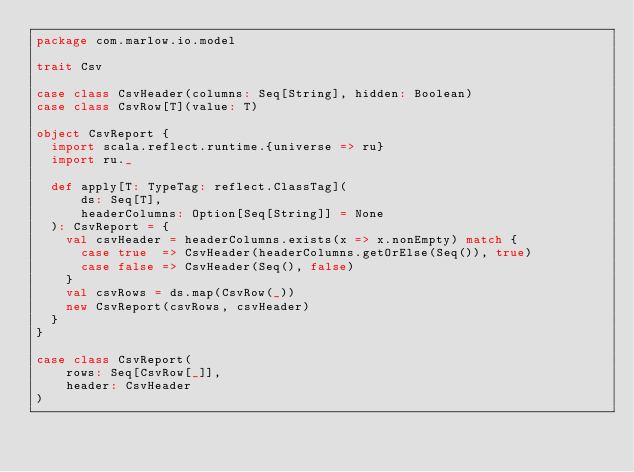<code> <loc_0><loc_0><loc_500><loc_500><_Scala_>package com.marlow.io.model

trait Csv

case class CsvHeader(columns: Seq[String], hidden: Boolean)
case class CsvRow[T](value: T)

object CsvReport {
  import scala.reflect.runtime.{universe => ru}
  import ru._

  def apply[T: TypeTag: reflect.ClassTag](
      ds: Seq[T],
      headerColumns: Option[Seq[String]] = None
  ): CsvReport = {
    val csvHeader = headerColumns.exists(x => x.nonEmpty) match {
      case true  => CsvHeader(headerColumns.getOrElse(Seq()), true)
      case false => CsvHeader(Seq(), false)
    }
    val csvRows = ds.map(CsvRow(_))
    new CsvReport(csvRows, csvHeader)
  }
}

case class CsvReport(
    rows: Seq[CsvRow[_]],
    header: CsvHeader
)
</code> 